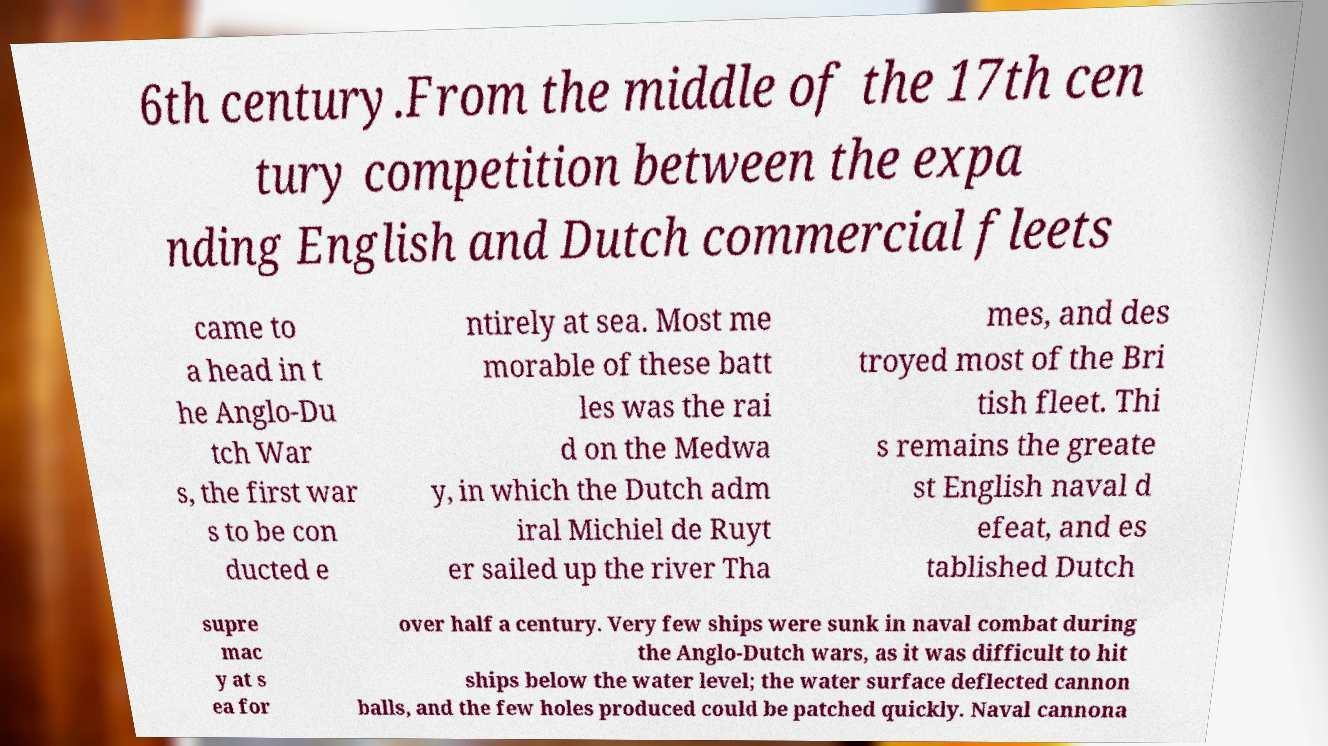I need the written content from this picture converted into text. Can you do that? 6th century.From the middle of the 17th cen tury competition between the expa nding English and Dutch commercial fleets came to a head in t he Anglo-Du tch War s, the first war s to be con ducted e ntirely at sea. Most me morable of these batt les was the rai d on the Medwa y, in which the Dutch adm iral Michiel de Ruyt er sailed up the river Tha mes, and des troyed most of the Bri tish fleet. Thi s remains the greate st English naval d efeat, and es tablished Dutch supre mac y at s ea for over half a century. Very few ships were sunk in naval combat during the Anglo-Dutch wars, as it was difficult to hit ships below the water level; the water surface deflected cannon balls, and the few holes produced could be patched quickly. Naval cannona 